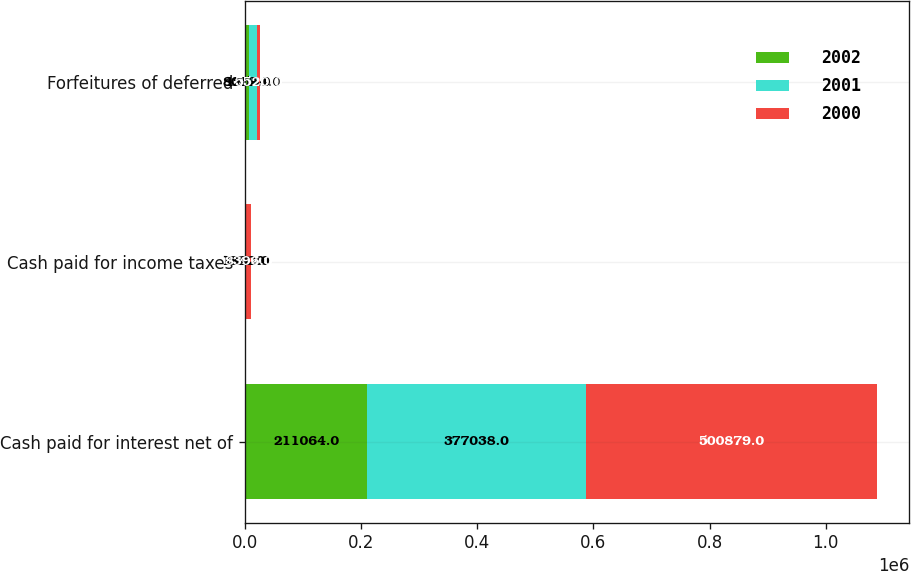Convert chart to OTSL. <chart><loc_0><loc_0><loc_500><loc_500><stacked_bar_chart><ecel><fcel>Cash paid for interest net of<fcel>Cash paid for income taxes<fcel>Forfeitures of deferred<nl><fcel>2002<fcel>211064<fcel>641<fcel>8072<nl><fcel>2001<fcel>377038<fcel>1832<fcel>12564<nl><fcel>2000<fcel>500879<fcel>8396<fcel>5520<nl></chart> 